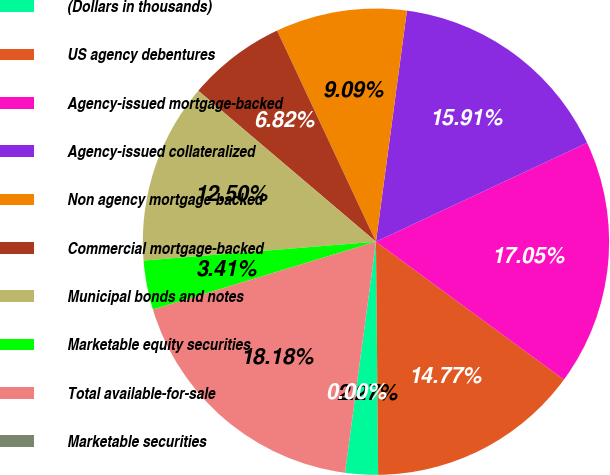Convert chart to OTSL. <chart><loc_0><loc_0><loc_500><loc_500><pie_chart><fcel>(Dollars in thousands)<fcel>US agency debentures<fcel>Agency-issued mortgage-backed<fcel>Agency-issued collateralized<fcel>Non agency mortgage-backed<fcel>Commercial mortgage-backed<fcel>Municipal bonds and notes<fcel>Marketable equity securities<fcel>Total available-for-sale<fcel>Marketable securities<nl><fcel>2.27%<fcel>14.77%<fcel>17.05%<fcel>15.91%<fcel>9.09%<fcel>6.82%<fcel>12.5%<fcel>3.41%<fcel>18.18%<fcel>0.0%<nl></chart> 